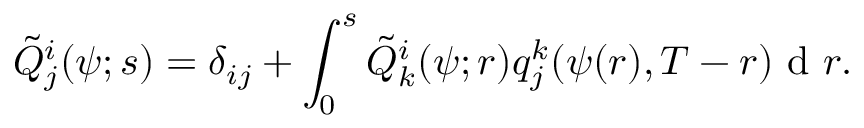<formula> <loc_0><loc_0><loc_500><loc_500>\tilde { Q } _ { j } ^ { i } ( \psi ; s ) = \delta _ { i j } + \int _ { 0 } ^ { s } \tilde { Q } _ { k } ^ { i } ( \psi ; r ) q _ { j } ^ { k } ( \psi ( r ) , T - r ) d r .</formula> 